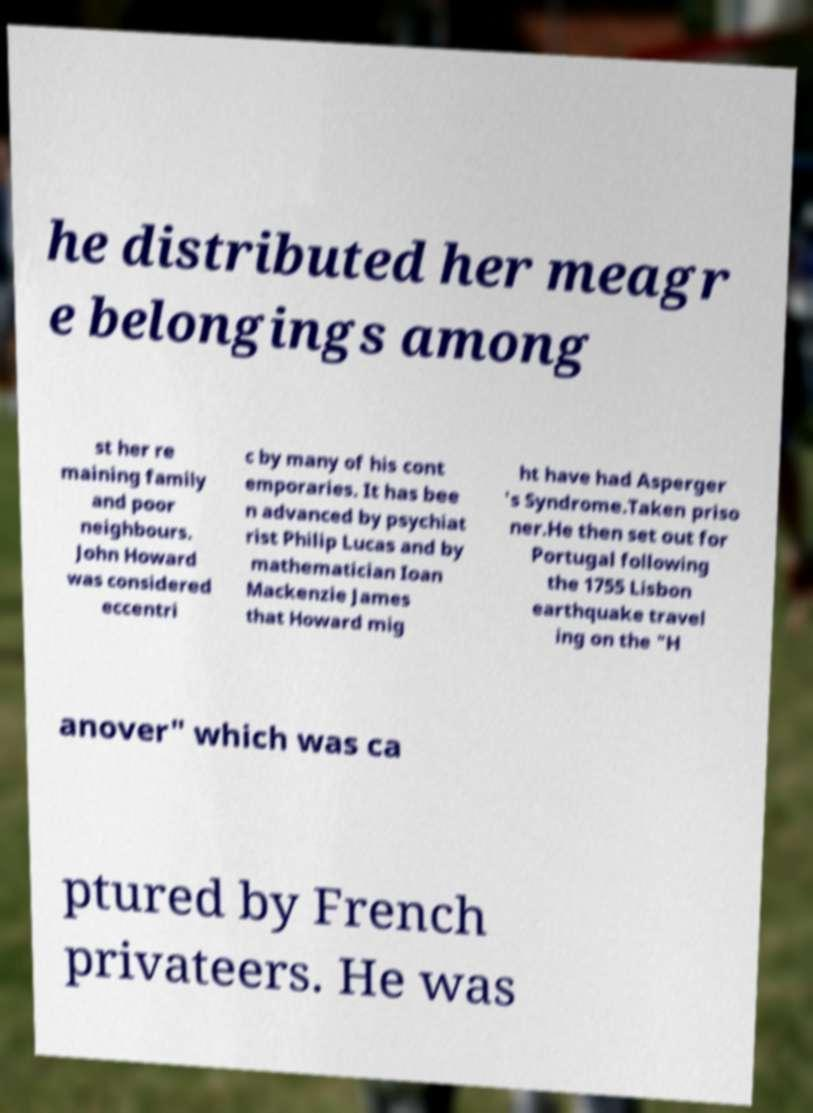Can you read and provide the text displayed in the image?This photo seems to have some interesting text. Can you extract and type it out for me? he distributed her meagr e belongings among st her re maining family and poor neighbours. John Howard was considered eccentri c by many of his cont emporaries. It has bee n advanced by psychiat rist Philip Lucas and by mathematician Ioan Mackenzie James that Howard mig ht have had Asperger 's Syndrome.Taken priso ner.He then set out for Portugal following the 1755 Lisbon earthquake travel ing on the "H anover" which was ca ptured by French privateers. He was 